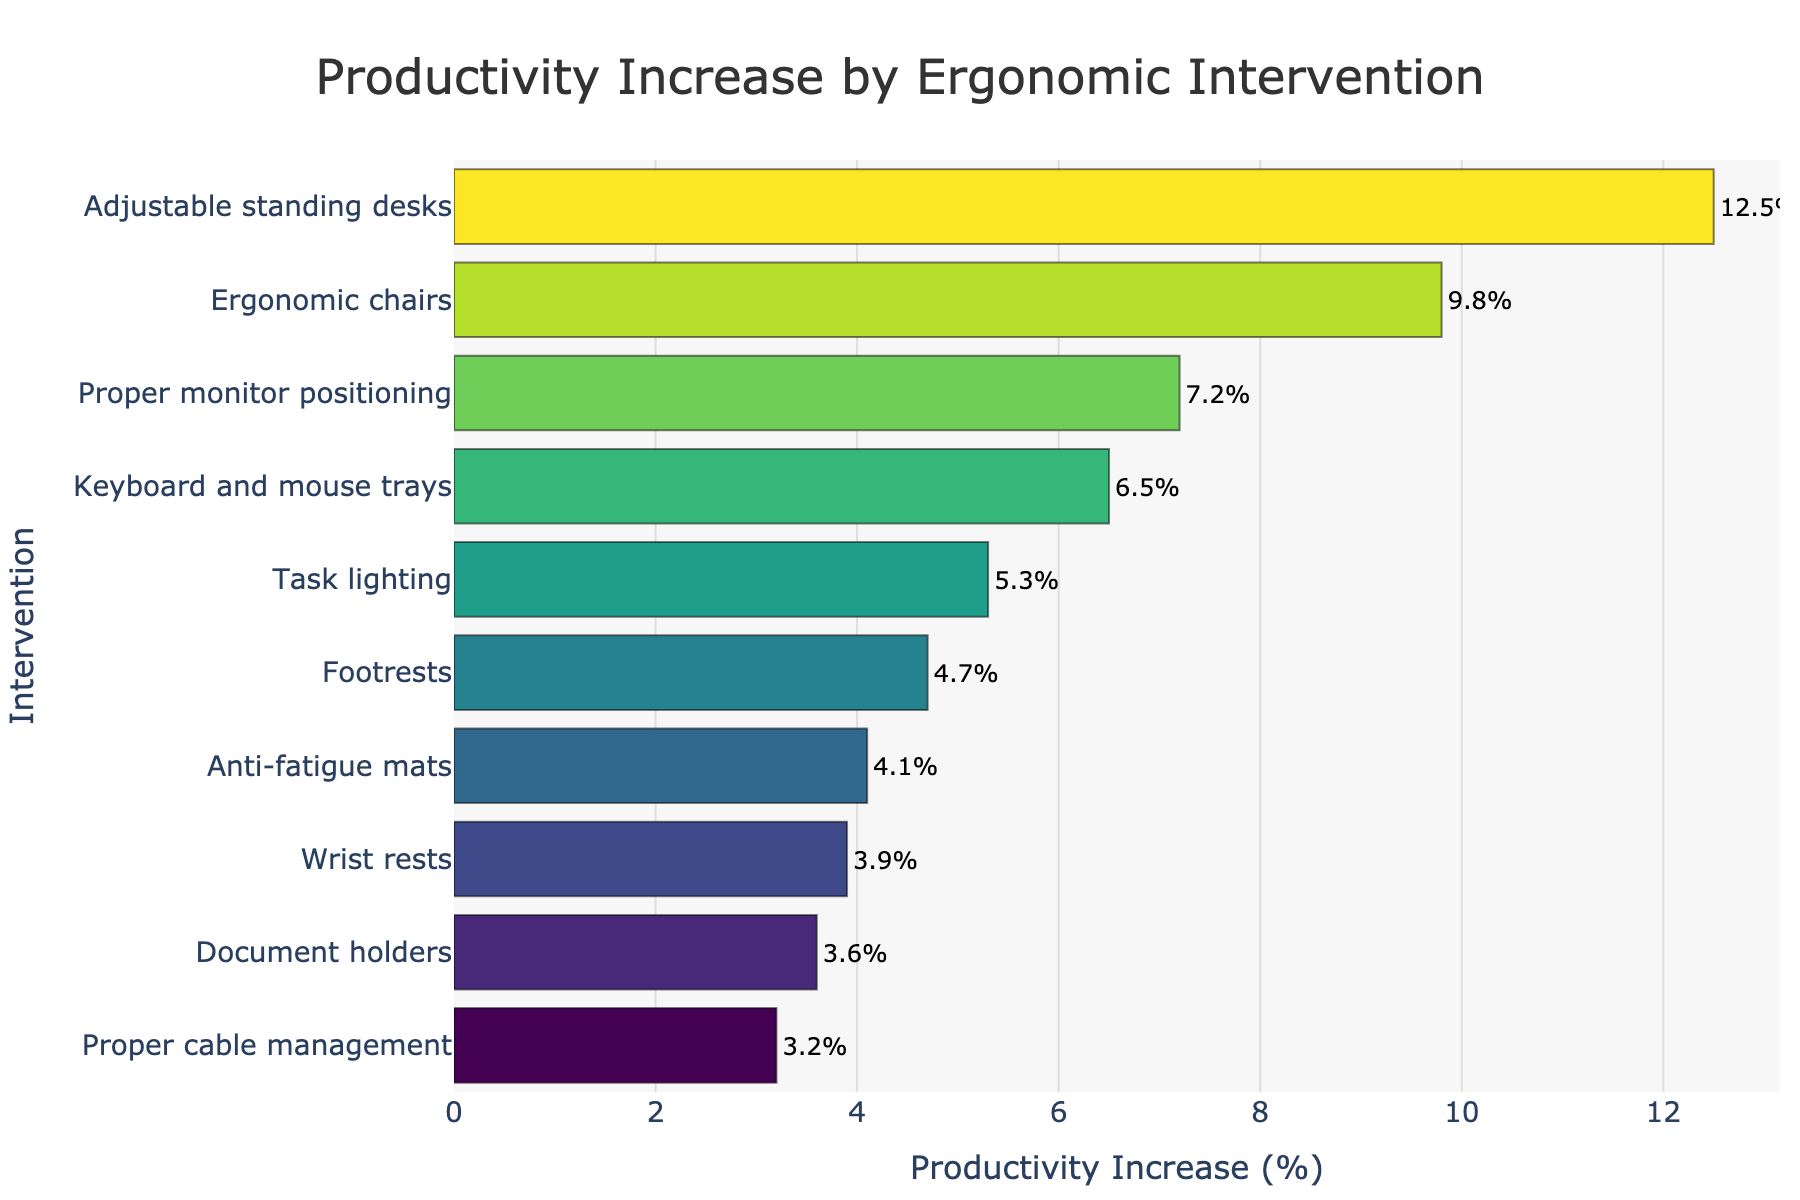what is the highest productivity increase intervention? The figure exhibits various ergonomic interventions along with the corresponding productivity increases. The bar for "Adjustable standing desks" is the longest, implying it has the highest increase.
Answer: Adjustable standing desks What is the smallest productivity increase intervention? By looking at the figure, the bar for "Proper cable management" is the shortest, indicating it has the smallest productivity increase.
Answer: Proper cable management How much more productivity increase do adjustable standing desks have compared to proper monitor positioning? From the figure, adjustable standing desks have a productivity increase of 12.5%, while proper monitor positioning has 7.2%. Subtract 7.2% from 12.5%. 12.5% - 7.2% = 5.3%
Answer: 5.3% Which intervention has a higher productivity increase: wrist rests or anti-fatigue mats? The lengths of the bars for both interventions show their productivity increases. Wrist rests have a productivity increase of 3.9%, while anti-fatigue mats have 4.1%. Since 4.1% > 3.9%, anti-fatigue mats are higher.
Answer: Anti-fatigue mats Are any interventions' productivity increases under 5%? To determine this, observe any bars that are shorter and represent values less than 5%. Footrests, anti-fatigue mats, wrist rests, document holders, and proper cable management all have values under 5%.
Answer: Yes Which intervention appears to utilize a green hue in the bar? Examining the color scheme applied to the bars of the different interventions, the intervention "Proper monitor positioning" appears painted in a more definite green hue.
Answer: Proper monitor positioning How much is the sum of productivity increases for ergonomic chairs and task lighting? Ergonomic chairs have a productivity increase of 9.8% and task lighting has 5.3%. Adding these two values: 9.8% + 5.3% = 15.1%
Answer: 15.1% What is the difference in productivity increase between task lighting and document holders? Task lighting has a productivity increase of 5.3% and document holders have 3.6%. Subtract 3.6% from 5.3%. 5.3% - 3.6% = 1.7%
Answer: 1.7% Which has a higher productivity increase: keyboard and mouse trays or footrests? From the figure, the bar for keyboard and mouse trays shows a productivity increase of 6.5%, while the bar for footrests shows 4.7%. Since 6.5% > 4.7%, keyboard and mouse trays are higher.
Answer: Keyboard and mouse trays 